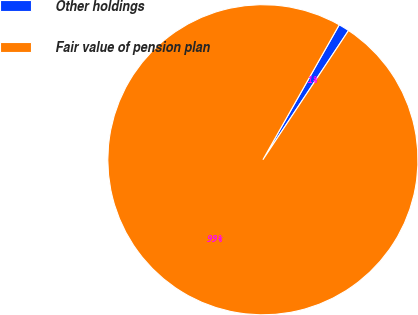Convert chart to OTSL. <chart><loc_0><loc_0><loc_500><loc_500><pie_chart><fcel>Other holdings<fcel>Fair value of pension plan<nl><fcel>1.12%<fcel>98.88%<nl></chart> 